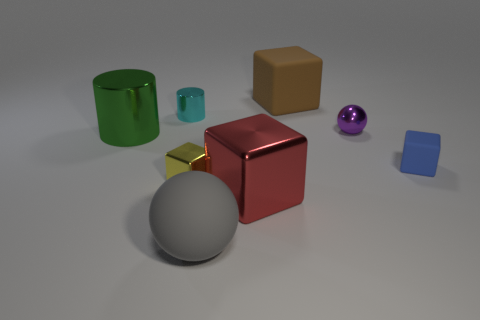What is the color of the metallic object that is both left of the yellow cube and on the right side of the big green metallic thing?
Make the answer very short. Cyan. The cube that is on the right side of the big block that is behind the big shiny object that is on the left side of the large gray thing is what color?
Your response must be concise. Blue. Are there fewer small blue blocks than tiny things?
Ensure brevity in your answer.  Yes. There is another metallic thing that is the same shape as the tiny cyan metallic thing; what is its color?
Your answer should be compact. Green. What is the color of the big thing that is the same material as the green cylinder?
Your answer should be compact. Red. What number of red objects are the same size as the metallic ball?
Make the answer very short. 0. What is the red object made of?
Your answer should be very brief. Metal. Is the number of small cyan objects greater than the number of tiny cyan matte cubes?
Provide a succinct answer. Yes. Does the tiny blue matte thing have the same shape as the big brown matte thing?
Your response must be concise. Yes. Are there any other things that have the same shape as the small blue rubber object?
Your response must be concise. Yes. 